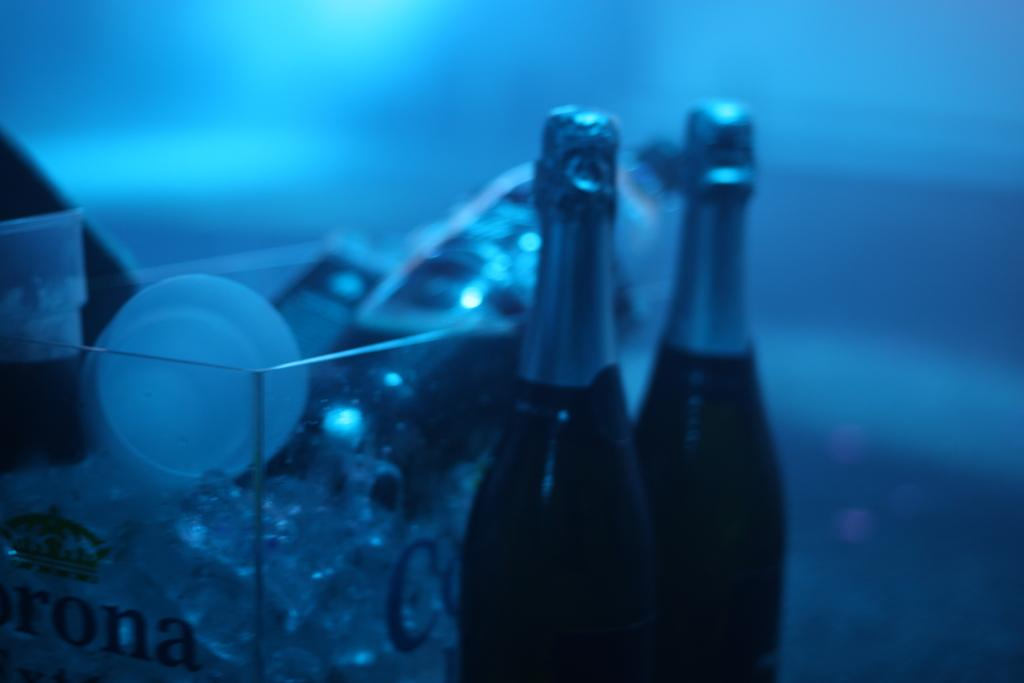<image>
Provide a brief description of the given image. Two bottles of champagne and a glass bucket with Corona. 